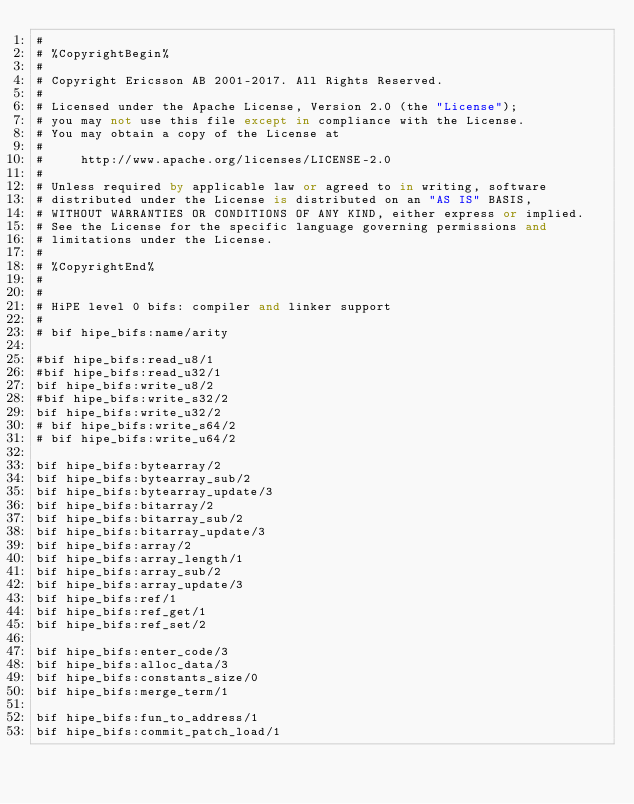Convert code to text. <code><loc_0><loc_0><loc_500><loc_500><_SQL_>#
# %CopyrightBegin%
#
# Copyright Ericsson AB 2001-2017. All Rights Reserved.
#
# Licensed under the Apache License, Version 2.0 (the "License");
# you may not use this file except in compliance with the License.
# You may obtain a copy of the License at
#
#     http://www.apache.org/licenses/LICENSE-2.0
#
# Unless required by applicable law or agreed to in writing, software
# distributed under the License is distributed on an "AS IS" BASIS,
# WITHOUT WARRANTIES OR CONDITIONS OF ANY KIND, either express or implied.
# See the License for the specific language governing permissions and
# limitations under the License.
#
# %CopyrightEnd%
#
#
# HiPE level 0 bifs: compiler and linker support
#
# bif hipe_bifs:name/arity

#bif hipe_bifs:read_u8/1
#bif hipe_bifs:read_u32/1
bif hipe_bifs:write_u8/2
#bif hipe_bifs:write_s32/2
bif hipe_bifs:write_u32/2
# bif hipe_bifs:write_s64/2
# bif hipe_bifs:write_u64/2

bif hipe_bifs:bytearray/2
bif hipe_bifs:bytearray_sub/2
bif hipe_bifs:bytearray_update/3
bif hipe_bifs:bitarray/2
bif hipe_bifs:bitarray_sub/2
bif hipe_bifs:bitarray_update/3
bif hipe_bifs:array/2
bif hipe_bifs:array_length/1
bif hipe_bifs:array_sub/2
bif hipe_bifs:array_update/3
bif hipe_bifs:ref/1
bif hipe_bifs:ref_get/1
bif hipe_bifs:ref_set/2

bif hipe_bifs:enter_code/3
bif hipe_bifs:alloc_data/3
bif hipe_bifs:constants_size/0
bif hipe_bifs:merge_term/1

bif hipe_bifs:fun_to_address/1
bif hipe_bifs:commit_patch_load/1</code> 